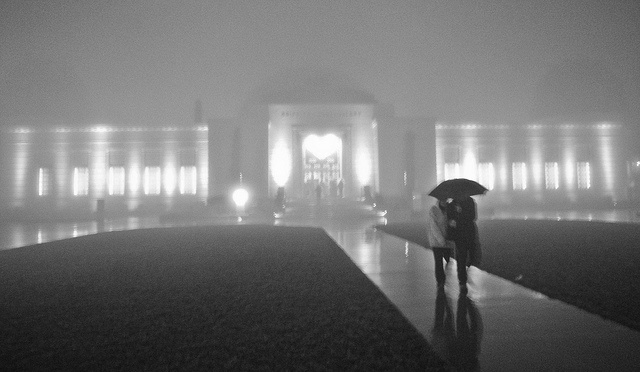Describe the objects in this image and their specific colors. I can see people in gray, black, and lightgray tones, people in gray, black, and lightgray tones, umbrella in gray, black, darkgray, and lightgray tones, people in lightgray, darkgray, and gray tones, and people in darkgray, lightgray, and gray tones in this image. 